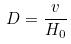<formula> <loc_0><loc_0><loc_500><loc_500>D = \frac { v } { H _ { 0 } }</formula> 